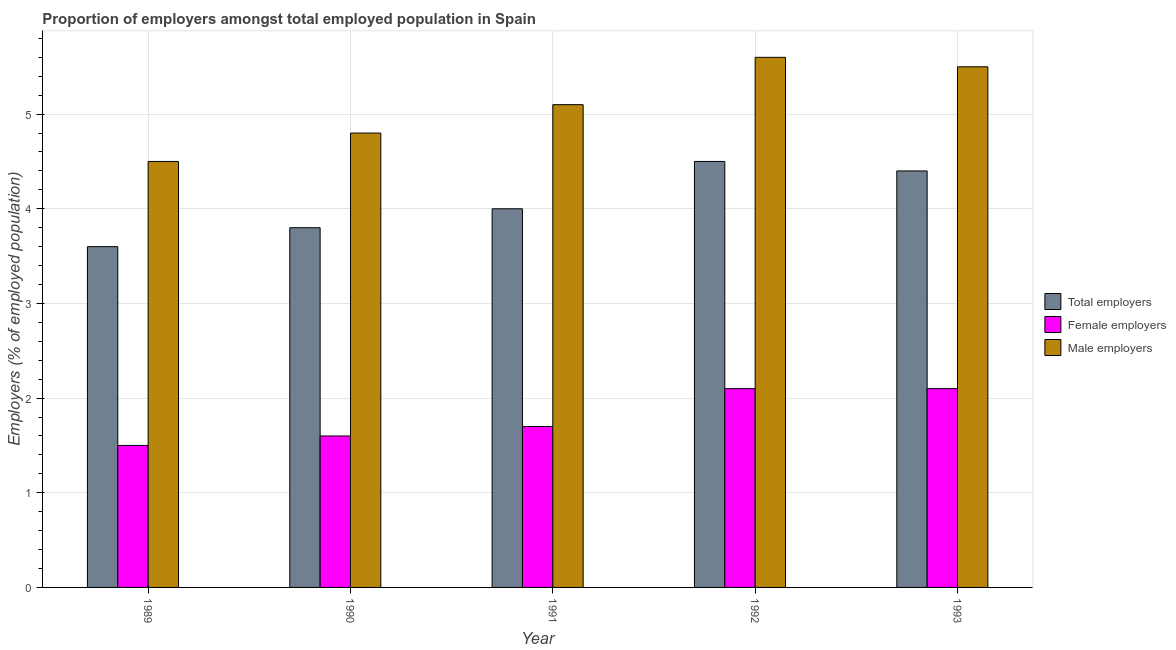Are the number of bars on each tick of the X-axis equal?
Your answer should be very brief. Yes. How many bars are there on the 5th tick from the left?
Your response must be concise. 3. How many bars are there on the 1st tick from the right?
Offer a very short reply. 3. What is the percentage of female employers in 1990?
Offer a very short reply. 1.6. Across all years, what is the maximum percentage of female employers?
Offer a terse response. 2.1. In which year was the percentage of female employers minimum?
Provide a succinct answer. 1989. What is the total percentage of male employers in the graph?
Your answer should be compact. 25.5. What is the difference between the percentage of female employers in 1989 and the percentage of total employers in 1992?
Your response must be concise. -0.6. What is the average percentage of male employers per year?
Provide a short and direct response. 5.1. In how many years, is the percentage of male employers greater than 0.4 %?
Ensure brevity in your answer.  5. What is the ratio of the percentage of total employers in 1989 to that in 1992?
Your answer should be compact. 0.8. What is the difference between the highest and the second highest percentage of total employers?
Provide a short and direct response. 0.1. What is the difference between the highest and the lowest percentage of male employers?
Ensure brevity in your answer.  1.1. Is the sum of the percentage of male employers in 1990 and 1992 greater than the maximum percentage of female employers across all years?
Provide a succinct answer. Yes. What does the 2nd bar from the left in 1989 represents?
Your answer should be compact. Female employers. What does the 2nd bar from the right in 1990 represents?
Make the answer very short. Female employers. How many bars are there?
Your answer should be very brief. 15. How many years are there in the graph?
Keep it short and to the point. 5. Are the values on the major ticks of Y-axis written in scientific E-notation?
Your answer should be compact. No. Does the graph contain any zero values?
Keep it short and to the point. No. How are the legend labels stacked?
Your response must be concise. Vertical. What is the title of the graph?
Give a very brief answer. Proportion of employers amongst total employed population in Spain. Does "Self-employed" appear as one of the legend labels in the graph?
Keep it short and to the point. No. What is the label or title of the Y-axis?
Provide a succinct answer. Employers (% of employed population). What is the Employers (% of employed population) in Total employers in 1989?
Keep it short and to the point. 3.6. What is the Employers (% of employed population) of Male employers in 1989?
Your response must be concise. 4.5. What is the Employers (% of employed population) of Total employers in 1990?
Make the answer very short. 3.8. What is the Employers (% of employed population) in Female employers in 1990?
Provide a succinct answer. 1.6. What is the Employers (% of employed population) in Male employers in 1990?
Make the answer very short. 4.8. What is the Employers (% of employed population) in Female employers in 1991?
Your answer should be very brief. 1.7. What is the Employers (% of employed population) in Male employers in 1991?
Give a very brief answer. 5.1. What is the Employers (% of employed population) in Total employers in 1992?
Make the answer very short. 4.5. What is the Employers (% of employed population) of Female employers in 1992?
Offer a very short reply. 2.1. What is the Employers (% of employed population) of Male employers in 1992?
Provide a short and direct response. 5.6. What is the Employers (% of employed population) of Total employers in 1993?
Offer a terse response. 4.4. What is the Employers (% of employed population) in Female employers in 1993?
Provide a succinct answer. 2.1. What is the Employers (% of employed population) in Male employers in 1993?
Give a very brief answer. 5.5. Across all years, what is the maximum Employers (% of employed population) of Female employers?
Ensure brevity in your answer.  2.1. Across all years, what is the maximum Employers (% of employed population) of Male employers?
Make the answer very short. 5.6. Across all years, what is the minimum Employers (% of employed population) of Total employers?
Your answer should be compact. 3.6. Across all years, what is the minimum Employers (% of employed population) of Female employers?
Provide a short and direct response. 1.5. Across all years, what is the minimum Employers (% of employed population) of Male employers?
Your answer should be very brief. 4.5. What is the total Employers (% of employed population) in Total employers in the graph?
Your answer should be compact. 20.3. What is the total Employers (% of employed population) in Male employers in the graph?
Offer a terse response. 25.5. What is the difference between the Employers (% of employed population) in Total employers in 1989 and that in 1990?
Provide a succinct answer. -0.2. What is the difference between the Employers (% of employed population) in Male employers in 1989 and that in 1990?
Your answer should be very brief. -0.3. What is the difference between the Employers (% of employed population) in Female employers in 1989 and that in 1991?
Your answer should be compact. -0.2. What is the difference between the Employers (% of employed population) in Total employers in 1989 and that in 1992?
Offer a very short reply. -0.9. What is the difference between the Employers (% of employed population) of Female employers in 1989 and that in 1992?
Provide a short and direct response. -0.6. What is the difference between the Employers (% of employed population) in Total employers in 1989 and that in 1993?
Provide a succinct answer. -0.8. What is the difference between the Employers (% of employed population) of Female employers in 1989 and that in 1993?
Give a very brief answer. -0.6. What is the difference between the Employers (% of employed population) of Male employers in 1989 and that in 1993?
Your answer should be compact. -1. What is the difference between the Employers (% of employed population) in Female employers in 1990 and that in 1991?
Your answer should be very brief. -0.1. What is the difference between the Employers (% of employed population) in Total employers in 1990 and that in 1992?
Offer a very short reply. -0.7. What is the difference between the Employers (% of employed population) in Female employers in 1990 and that in 1992?
Your answer should be very brief. -0.5. What is the difference between the Employers (% of employed population) in Male employers in 1990 and that in 1993?
Your answer should be compact. -0.7. What is the difference between the Employers (% of employed population) in Female employers in 1991 and that in 1992?
Provide a succinct answer. -0.4. What is the difference between the Employers (% of employed population) of Male employers in 1991 and that in 1992?
Your answer should be very brief. -0.5. What is the difference between the Employers (% of employed population) of Total employers in 1991 and that in 1993?
Your answer should be compact. -0.4. What is the difference between the Employers (% of employed population) of Female employers in 1991 and that in 1993?
Ensure brevity in your answer.  -0.4. What is the difference between the Employers (% of employed population) in Female employers in 1989 and the Employers (% of employed population) in Male employers in 1990?
Offer a very short reply. -3.3. What is the difference between the Employers (% of employed population) of Total employers in 1989 and the Employers (% of employed population) of Female employers in 1992?
Provide a short and direct response. 1.5. What is the difference between the Employers (% of employed population) in Female employers in 1989 and the Employers (% of employed population) in Male employers in 1993?
Keep it short and to the point. -4. What is the difference between the Employers (% of employed population) of Total employers in 1990 and the Employers (% of employed population) of Female employers in 1991?
Your answer should be compact. 2.1. What is the difference between the Employers (% of employed population) in Total employers in 1990 and the Employers (% of employed population) in Male employers in 1991?
Offer a terse response. -1.3. What is the difference between the Employers (% of employed population) in Female employers in 1990 and the Employers (% of employed population) in Male employers in 1991?
Keep it short and to the point. -3.5. What is the difference between the Employers (% of employed population) of Female employers in 1990 and the Employers (% of employed population) of Male employers in 1992?
Provide a short and direct response. -4. What is the difference between the Employers (% of employed population) of Total employers in 1990 and the Employers (% of employed population) of Male employers in 1993?
Give a very brief answer. -1.7. What is the difference between the Employers (% of employed population) of Female employers in 1990 and the Employers (% of employed population) of Male employers in 1993?
Make the answer very short. -3.9. What is the difference between the Employers (% of employed population) in Total employers in 1991 and the Employers (% of employed population) in Female employers in 1992?
Your answer should be compact. 1.9. What is the difference between the Employers (% of employed population) of Total employers in 1991 and the Employers (% of employed population) of Female employers in 1993?
Offer a very short reply. 1.9. What is the difference between the Employers (% of employed population) in Total employers in 1992 and the Employers (% of employed population) in Male employers in 1993?
Your answer should be compact. -1. What is the average Employers (% of employed population) in Total employers per year?
Give a very brief answer. 4.06. What is the average Employers (% of employed population) of Female employers per year?
Your answer should be compact. 1.8. In the year 1990, what is the difference between the Employers (% of employed population) of Female employers and Employers (% of employed population) of Male employers?
Ensure brevity in your answer.  -3.2. In the year 1991, what is the difference between the Employers (% of employed population) in Total employers and Employers (% of employed population) in Female employers?
Give a very brief answer. 2.3. In the year 1991, what is the difference between the Employers (% of employed population) of Total employers and Employers (% of employed population) of Male employers?
Give a very brief answer. -1.1. In the year 1991, what is the difference between the Employers (% of employed population) of Female employers and Employers (% of employed population) of Male employers?
Ensure brevity in your answer.  -3.4. In the year 1992, what is the difference between the Employers (% of employed population) of Total employers and Employers (% of employed population) of Female employers?
Make the answer very short. 2.4. In the year 1993, what is the difference between the Employers (% of employed population) of Total employers and Employers (% of employed population) of Female employers?
Give a very brief answer. 2.3. What is the ratio of the Employers (% of employed population) of Total employers in 1989 to that in 1990?
Give a very brief answer. 0.95. What is the ratio of the Employers (% of employed population) in Male employers in 1989 to that in 1990?
Provide a short and direct response. 0.94. What is the ratio of the Employers (% of employed population) of Female employers in 1989 to that in 1991?
Your response must be concise. 0.88. What is the ratio of the Employers (% of employed population) of Male employers in 1989 to that in 1991?
Your answer should be very brief. 0.88. What is the ratio of the Employers (% of employed population) in Total employers in 1989 to that in 1992?
Ensure brevity in your answer.  0.8. What is the ratio of the Employers (% of employed population) in Male employers in 1989 to that in 1992?
Ensure brevity in your answer.  0.8. What is the ratio of the Employers (% of employed population) of Total employers in 1989 to that in 1993?
Ensure brevity in your answer.  0.82. What is the ratio of the Employers (% of employed population) in Male employers in 1989 to that in 1993?
Your response must be concise. 0.82. What is the ratio of the Employers (% of employed population) of Total employers in 1990 to that in 1991?
Make the answer very short. 0.95. What is the ratio of the Employers (% of employed population) in Female employers in 1990 to that in 1991?
Your response must be concise. 0.94. What is the ratio of the Employers (% of employed population) of Total employers in 1990 to that in 1992?
Your response must be concise. 0.84. What is the ratio of the Employers (% of employed population) of Female employers in 1990 to that in 1992?
Ensure brevity in your answer.  0.76. What is the ratio of the Employers (% of employed population) of Male employers in 1990 to that in 1992?
Keep it short and to the point. 0.86. What is the ratio of the Employers (% of employed population) in Total employers in 1990 to that in 1993?
Your answer should be very brief. 0.86. What is the ratio of the Employers (% of employed population) in Female employers in 1990 to that in 1993?
Your answer should be compact. 0.76. What is the ratio of the Employers (% of employed population) of Male employers in 1990 to that in 1993?
Ensure brevity in your answer.  0.87. What is the ratio of the Employers (% of employed population) in Total employers in 1991 to that in 1992?
Ensure brevity in your answer.  0.89. What is the ratio of the Employers (% of employed population) of Female employers in 1991 to that in 1992?
Offer a terse response. 0.81. What is the ratio of the Employers (% of employed population) in Male employers in 1991 to that in 1992?
Your response must be concise. 0.91. What is the ratio of the Employers (% of employed population) of Female employers in 1991 to that in 1993?
Provide a succinct answer. 0.81. What is the ratio of the Employers (% of employed population) in Male employers in 1991 to that in 1993?
Provide a short and direct response. 0.93. What is the ratio of the Employers (% of employed population) of Total employers in 1992 to that in 1993?
Make the answer very short. 1.02. What is the ratio of the Employers (% of employed population) of Female employers in 1992 to that in 1993?
Provide a succinct answer. 1. What is the ratio of the Employers (% of employed population) in Male employers in 1992 to that in 1993?
Provide a short and direct response. 1.02. What is the difference between the highest and the lowest Employers (% of employed population) in Female employers?
Provide a succinct answer. 0.6. What is the difference between the highest and the lowest Employers (% of employed population) of Male employers?
Give a very brief answer. 1.1. 